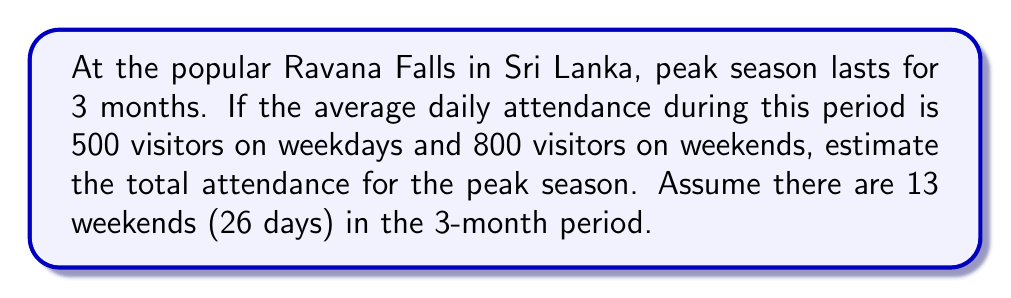Help me with this question. Let's break this down step-by-step:

1. Calculate the number of days in the peak season:
   3 months ≈ 90 days

2. Calculate the number of weekdays:
   Total days - Weekend days = 90 - 26 = 64 weekdays

3. Calculate attendance for weekdays:
   $500 \text{ visitors} \times 64 \text{ days} = 32,000 \text{ visitors}$

4. Calculate attendance for weekends:
   $800 \text{ visitors} \times 26 \text{ days} = 20,800 \text{ visitors}$

5. Sum up the total attendance:
   $32,000 + 20,800 = 52,800 \text{ visitors}$

Therefore, the estimated total attendance at Ravana Falls during the peak season is 52,800 visitors.
Answer: 52,800 visitors 